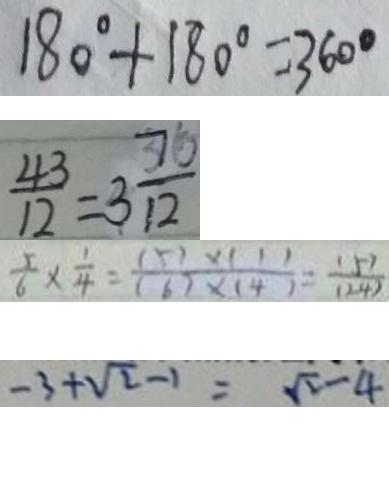<formula> <loc_0><loc_0><loc_500><loc_500>1 8 0 ^ { \circ } + 1 8 0 ^ { \circ } = 3 6 0 ^ { \circ } 
 \frac { 4 3 } { 1 2 } = 3 \frac { 7 } { 1 2 } 
 \frac { 5 } { 6 } \times \frac { 1 } { 4 } = \frac { ( 5 ) \times ( 1 ) } { ( 6 ) \times ( 4 ) } = \frac { ( 5 ) } { ( 2 4 ) } 
 - 3 + \sqrt { 2 } - 1 = \sqrt { 2 } - 4</formula> 